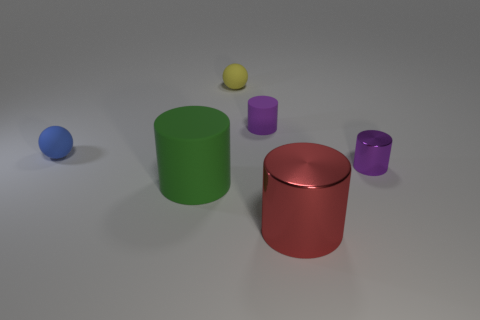What is the material of the other cylinder that is the same color as the tiny shiny cylinder?
Offer a very short reply. Rubber. How big is the cylinder on the right side of the red metallic cylinder that is to the right of the large green rubber thing?
Your answer should be compact. Small. How many large things are either cyan objects or red objects?
Provide a succinct answer. 1. Are there fewer tiny cylinders than large purple shiny objects?
Keep it short and to the point. No. Is there any other thing that has the same size as the blue object?
Provide a short and direct response. Yes. Does the big rubber cylinder have the same color as the tiny metallic object?
Your answer should be compact. No. Is the number of red metallic things greater than the number of tiny gray matte things?
Your answer should be very brief. Yes. What number of other things are there of the same color as the small rubber cylinder?
Your answer should be very brief. 1. There is a tiny cylinder that is right of the large red object; what number of yellow things are in front of it?
Offer a very short reply. 0. Are there any things in front of the large green matte thing?
Make the answer very short. Yes. 